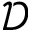<formula> <loc_0><loc_0><loc_500><loc_500>\mathcal { D }</formula> 